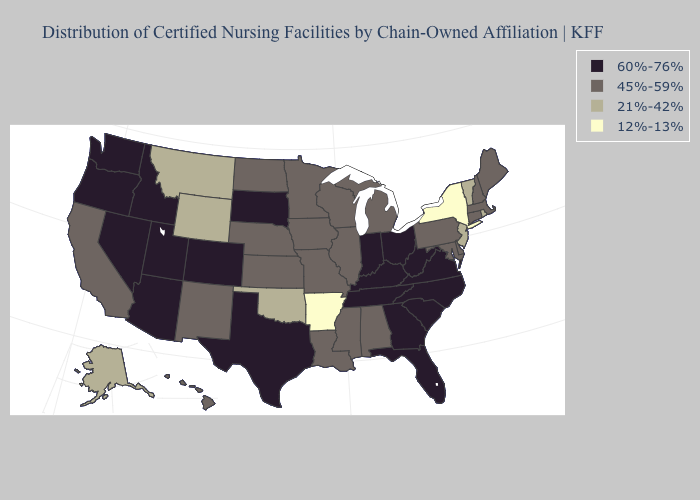What is the highest value in states that border Nevada?
Concise answer only. 60%-76%. Among the states that border Illinois , which have the highest value?
Quick response, please. Indiana, Kentucky. Among the states that border Delaware , does Pennsylvania have the lowest value?
Answer briefly. No. What is the lowest value in states that border Texas?
Write a very short answer. 12%-13%. What is the value of Alabama?
Give a very brief answer. 45%-59%. Is the legend a continuous bar?
Answer briefly. No. Does the map have missing data?
Short answer required. No. Is the legend a continuous bar?
Concise answer only. No. Among the states that border Texas , does Arkansas have the highest value?
Quick response, please. No. What is the lowest value in states that border Kansas?
Write a very short answer. 21%-42%. Name the states that have a value in the range 21%-42%?
Quick response, please. Alaska, Montana, New Jersey, Oklahoma, Rhode Island, Vermont, Wyoming. Name the states that have a value in the range 45%-59%?
Answer briefly. Alabama, California, Connecticut, Delaware, Hawaii, Illinois, Iowa, Kansas, Louisiana, Maine, Maryland, Massachusetts, Michigan, Minnesota, Mississippi, Missouri, Nebraska, New Hampshire, New Mexico, North Dakota, Pennsylvania, Wisconsin. Does Virginia have the highest value in the USA?
Be succinct. Yes. Does New York have the lowest value in the USA?
Short answer required. Yes. 